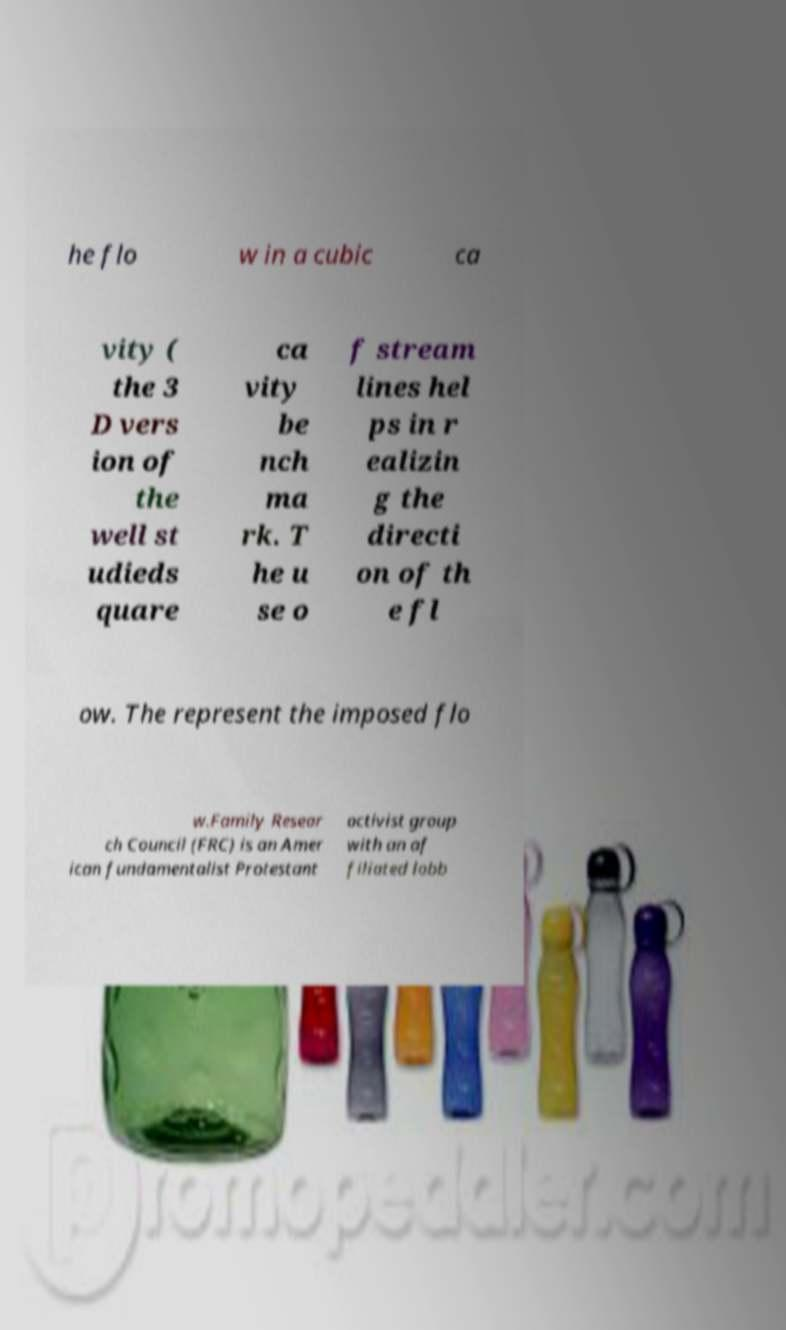There's text embedded in this image that I need extracted. Can you transcribe it verbatim? he flo w in a cubic ca vity ( the 3 D vers ion of the well st udieds quare ca vity be nch ma rk. T he u se o f stream lines hel ps in r ealizin g the directi on of th e fl ow. The represent the imposed flo w.Family Resear ch Council (FRC) is an Amer ican fundamentalist Protestant activist group with an af filiated lobb 